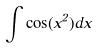<formula> <loc_0><loc_0><loc_500><loc_500>\int \cos ( x ^ { 2 } ) d x</formula> 